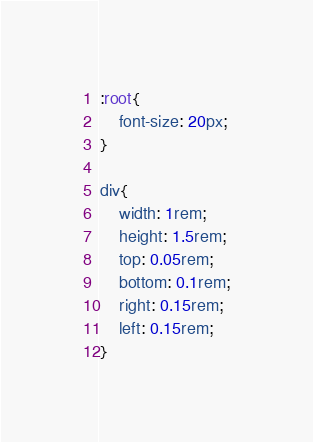Convert code to text. <code><loc_0><loc_0><loc_500><loc_500><_CSS_>:root{
	font-size: 20px;
}

div{
	width: 1rem;
	height: 1.5rem;
	top: 0.05rem;
	bottom: 0.1rem;
	right: 0.15rem;
	left: 0.15rem;
}
</code> 